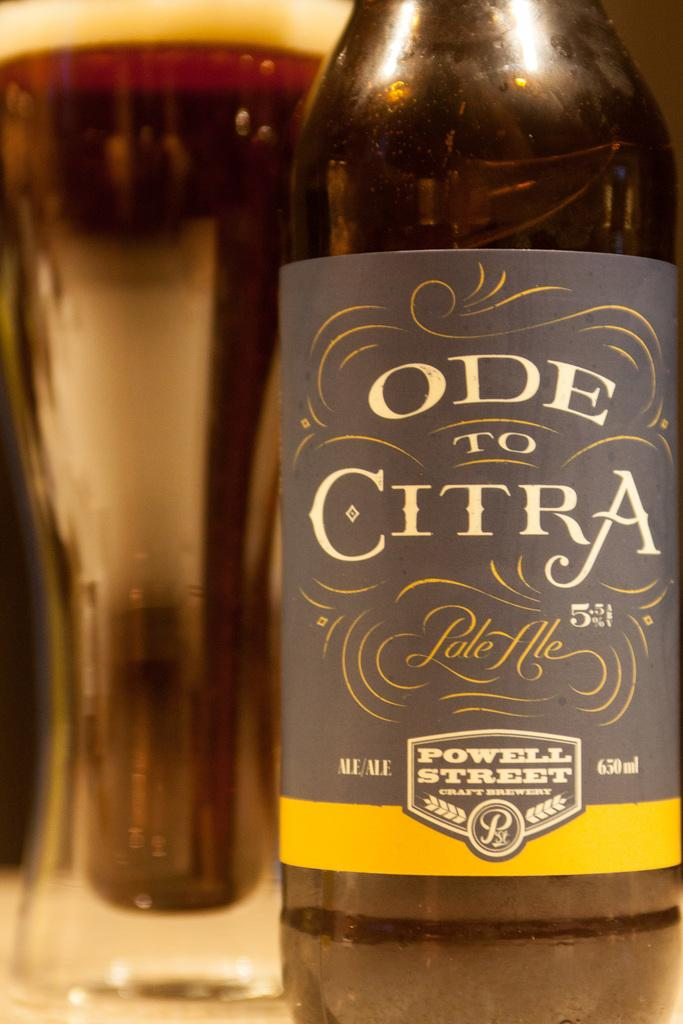<image>
Create a compact narrative representing the image presented. Behind a bottle of Ode To Citra is a glass full of a brown beverage. 